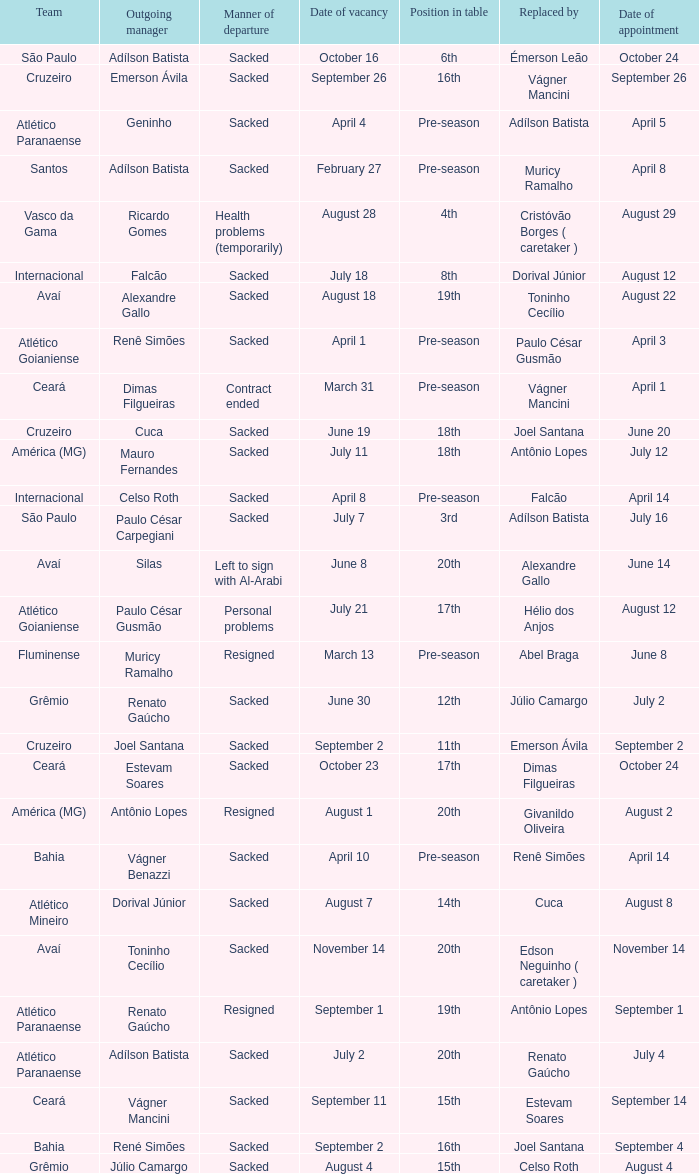Parse the table in full. {'header': ['Team', 'Outgoing manager', 'Manner of departure', 'Date of vacancy', 'Position in table', 'Replaced by', 'Date of appointment'], 'rows': [['São Paulo', 'Adílson Batista', 'Sacked', 'October 16', '6th', 'Émerson Leão', 'October 24'], ['Cruzeiro', 'Emerson Ávila', 'Sacked', 'September 26', '16th', 'Vágner Mancini', 'September 26'], ['Atlético Paranaense', 'Geninho', 'Sacked', 'April 4', 'Pre-season', 'Adílson Batista', 'April 5'], ['Santos', 'Adílson Batista', 'Sacked', 'February 27', 'Pre-season', 'Muricy Ramalho', 'April 8'], ['Vasco da Gama', 'Ricardo Gomes', 'Health problems (temporarily)', 'August 28', '4th', 'Cristóvão Borges ( caretaker )', 'August 29'], ['Internacional', 'Falcão', 'Sacked', 'July 18', '8th', 'Dorival Júnior', 'August 12'], ['Avaí', 'Alexandre Gallo', 'Sacked', 'August 18', '19th', 'Toninho Cecílio', 'August 22'], ['Atlético Goianiense', 'Renê Simões', 'Sacked', 'April 1', 'Pre-season', 'Paulo César Gusmão', 'April 3'], ['Ceará', 'Dimas Filgueiras', 'Contract ended', 'March 31', 'Pre-season', 'Vágner Mancini', 'April 1'], ['Cruzeiro', 'Cuca', 'Sacked', 'June 19', '18th', 'Joel Santana', 'June 20'], ['América (MG)', 'Mauro Fernandes', 'Sacked', 'July 11', '18th', 'Antônio Lopes', 'July 12'], ['Internacional', 'Celso Roth', 'Sacked', 'April 8', 'Pre-season', 'Falcão', 'April 14'], ['São Paulo', 'Paulo César Carpegiani', 'Sacked', 'July 7', '3rd', 'Adílson Batista', 'July 16'], ['Avaí', 'Silas', 'Left to sign with Al-Arabi', 'June 8', '20th', 'Alexandre Gallo', 'June 14'], ['Atlético Goianiense', 'Paulo César Gusmão', 'Personal problems', 'July 21', '17th', 'Hélio dos Anjos', 'August 12'], ['Fluminense', 'Muricy Ramalho', 'Resigned', 'March 13', 'Pre-season', 'Abel Braga', 'June 8'], ['Grêmio', 'Renato Gaúcho', 'Sacked', 'June 30', '12th', 'Júlio Camargo', 'July 2'], ['Cruzeiro', 'Joel Santana', 'Sacked', 'September 2', '11th', 'Emerson Ávila', 'September 2'], ['Ceará', 'Estevam Soares', 'Sacked', 'October 23', '17th', 'Dimas Filgueiras', 'October 24'], ['América (MG)', 'Antônio Lopes', 'Resigned', 'August 1', '20th', 'Givanildo Oliveira', 'August 2'], ['Bahia', 'Vágner Benazzi', 'Sacked', 'April 10', 'Pre-season', 'Renê Simões', 'April 14'], ['Atlético Mineiro', 'Dorival Júnior', 'Sacked', 'August 7', '14th', 'Cuca', 'August 8'], ['Avaí', 'Toninho Cecílio', 'Sacked', 'November 14', '20th', 'Edson Neguinho ( caretaker )', 'November 14'], ['Atlético Paranaense', 'Renato Gaúcho', 'Resigned', 'September 1', '19th', 'Antônio Lopes', 'September 1'], ['Atlético Paranaense', 'Adílson Batista', 'Sacked', 'July 2', '20th', 'Renato Gaúcho', 'July 4'], ['Ceará', 'Vágner Mancini', 'Sacked', 'September 11', '15th', 'Estevam Soares', 'September 14'], ['Bahia', 'René Simões', 'Sacked', 'September 2', '16th', 'Joel Santana', 'September 4'], ['Grêmio', 'Júlio Camargo', 'Sacked', 'August 4', '15th', 'Celso Roth', 'August 4']]} How many times did Silas leave as a team manager? 1.0. 